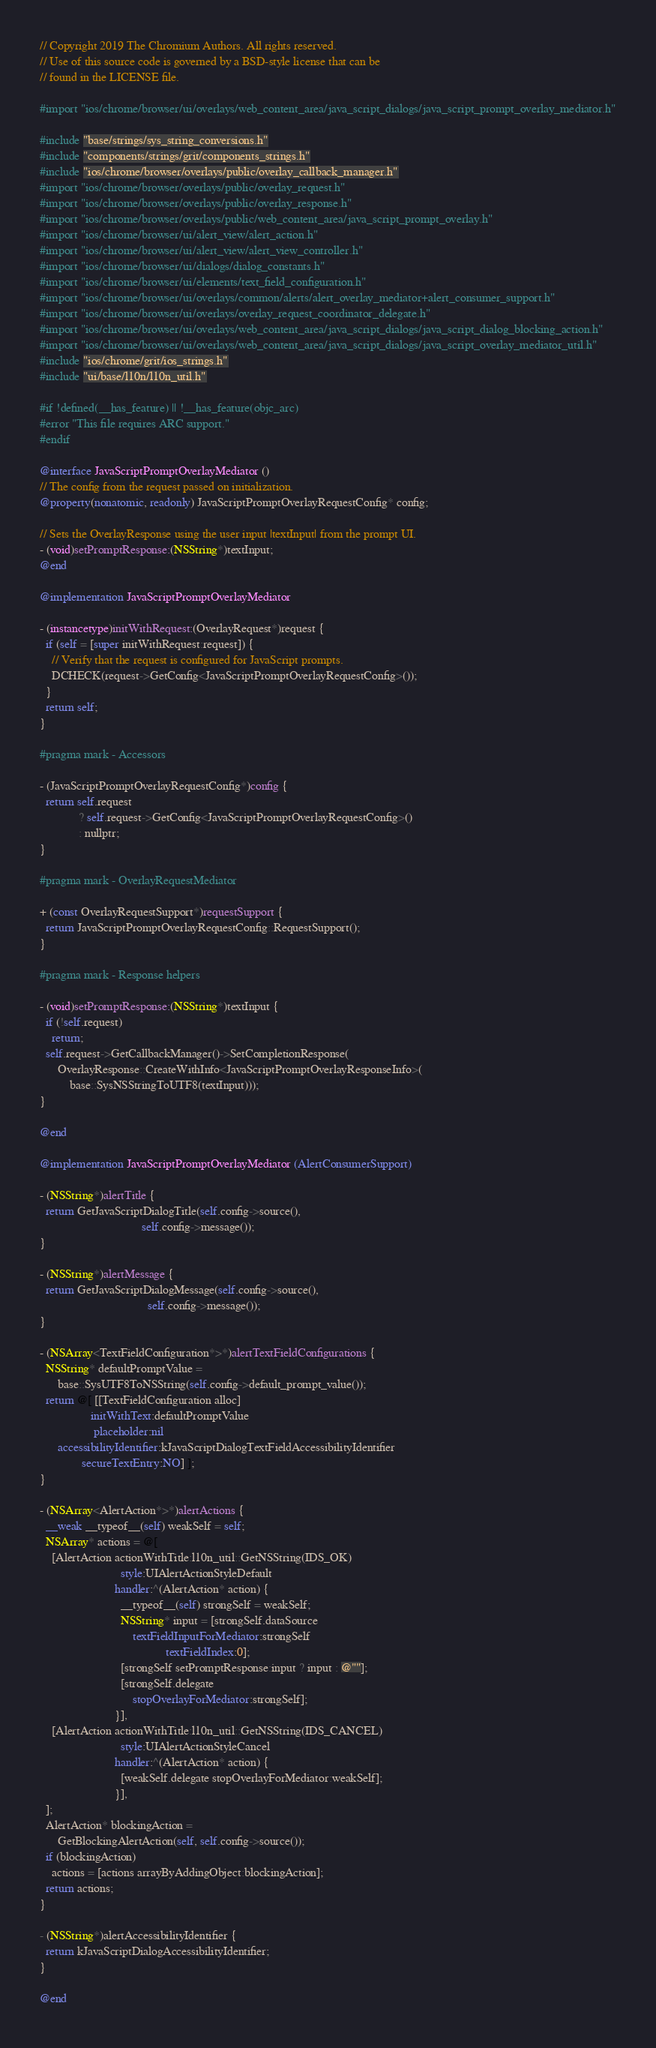<code> <loc_0><loc_0><loc_500><loc_500><_ObjectiveC_>// Copyright 2019 The Chromium Authors. All rights reserved.
// Use of this source code is governed by a BSD-style license that can be
// found in the LICENSE file.

#import "ios/chrome/browser/ui/overlays/web_content_area/java_script_dialogs/java_script_prompt_overlay_mediator.h"

#include "base/strings/sys_string_conversions.h"
#include "components/strings/grit/components_strings.h"
#include "ios/chrome/browser/overlays/public/overlay_callback_manager.h"
#import "ios/chrome/browser/overlays/public/overlay_request.h"
#import "ios/chrome/browser/overlays/public/overlay_response.h"
#import "ios/chrome/browser/overlays/public/web_content_area/java_script_prompt_overlay.h"
#import "ios/chrome/browser/ui/alert_view/alert_action.h"
#import "ios/chrome/browser/ui/alert_view/alert_view_controller.h"
#import "ios/chrome/browser/ui/dialogs/dialog_constants.h"
#import "ios/chrome/browser/ui/elements/text_field_configuration.h"
#import "ios/chrome/browser/ui/overlays/common/alerts/alert_overlay_mediator+alert_consumer_support.h"
#import "ios/chrome/browser/ui/overlays/overlay_request_coordinator_delegate.h"
#import "ios/chrome/browser/ui/overlays/web_content_area/java_script_dialogs/java_script_dialog_blocking_action.h"
#import "ios/chrome/browser/ui/overlays/web_content_area/java_script_dialogs/java_script_overlay_mediator_util.h"
#include "ios/chrome/grit/ios_strings.h"
#include "ui/base/l10n/l10n_util.h"

#if !defined(__has_feature) || !__has_feature(objc_arc)
#error "This file requires ARC support."
#endif

@interface JavaScriptPromptOverlayMediator ()
// The config from the request passed on initialization.
@property(nonatomic, readonly) JavaScriptPromptOverlayRequestConfig* config;

// Sets the OverlayResponse using the user input |textInput| from the prompt UI.
- (void)setPromptResponse:(NSString*)textInput;
@end

@implementation JavaScriptPromptOverlayMediator

- (instancetype)initWithRequest:(OverlayRequest*)request {
  if (self = [super initWithRequest:request]) {
    // Verify that the request is configured for JavaScript prompts.
    DCHECK(request->GetConfig<JavaScriptPromptOverlayRequestConfig>());
  }
  return self;
}

#pragma mark - Accessors

- (JavaScriptPromptOverlayRequestConfig*)config {
  return self.request
             ? self.request->GetConfig<JavaScriptPromptOverlayRequestConfig>()
             : nullptr;
}

#pragma mark - OverlayRequestMediator

+ (const OverlayRequestSupport*)requestSupport {
  return JavaScriptPromptOverlayRequestConfig::RequestSupport();
}

#pragma mark - Response helpers

- (void)setPromptResponse:(NSString*)textInput {
  if (!self.request)
    return;
  self.request->GetCallbackManager()->SetCompletionResponse(
      OverlayResponse::CreateWithInfo<JavaScriptPromptOverlayResponseInfo>(
          base::SysNSStringToUTF8(textInput)));
}

@end

@implementation JavaScriptPromptOverlayMediator (AlertConsumerSupport)

- (NSString*)alertTitle {
  return GetJavaScriptDialogTitle(self.config->source(),
                                  self.config->message());
}

- (NSString*)alertMessage {
  return GetJavaScriptDialogMessage(self.config->source(),
                                    self.config->message());
}

- (NSArray<TextFieldConfiguration*>*)alertTextFieldConfigurations {
  NSString* defaultPromptValue =
      base::SysUTF8ToNSString(self.config->default_prompt_value());
  return @[ [[TextFieldConfiguration alloc]
                 initWithText:defaultPromptValue
                  placeholder:nil
      accessibilityIdentifier:kJavaScriptDialogTextFieldAccessibilityIdentifier
              secureTextEntry:NO] ];
}

- (NSArray<AlertAction*>*)alertActions {
  __weak __typeof__(self) weakSelf = self;
  NSArray* actions = @[
    [AlertAction actionWithTitle:l10n_util::GetNSString(IDS_OK)
                           style:UIAlertActionStyleDefault
                         handler:^(AlertAction* action) {
                           __typeof__(self) strongSelf = weakSelf;
                           NSString* input = [strongSelf.dataSource
                               textFieldInputForMediator:strongSelf
                                          textFieldIndex:0];
                           [strongSelf setPromptResponse:input ? input : @""];
                           [strongSelf.delegate
                               stopOverlayForMediator:strongSelf];
                         }],
    [AlertAction actionWithTitle:l10n_util::GetNSString(IDS_CANCEL)
                           style:UIAlertActionStyleCancel
                         handler:^(AlertAction* action) {
                           [weakSelf.delegate stopOverlayForMediator:weakSelf];
                         }],
  ];
  AlertAction* blockingAction =
      GetBlockingAlertAction(self, self.config->source());
  if (blockingAction)
    actions = [actions arrayByAddingObject:blockingAction];
  return actions;
}

- (NSString*)alertAccessibilityIdentifier {
  return kJavaScriptDialogAccessibilityIdentifier;
}

@end
</code> 